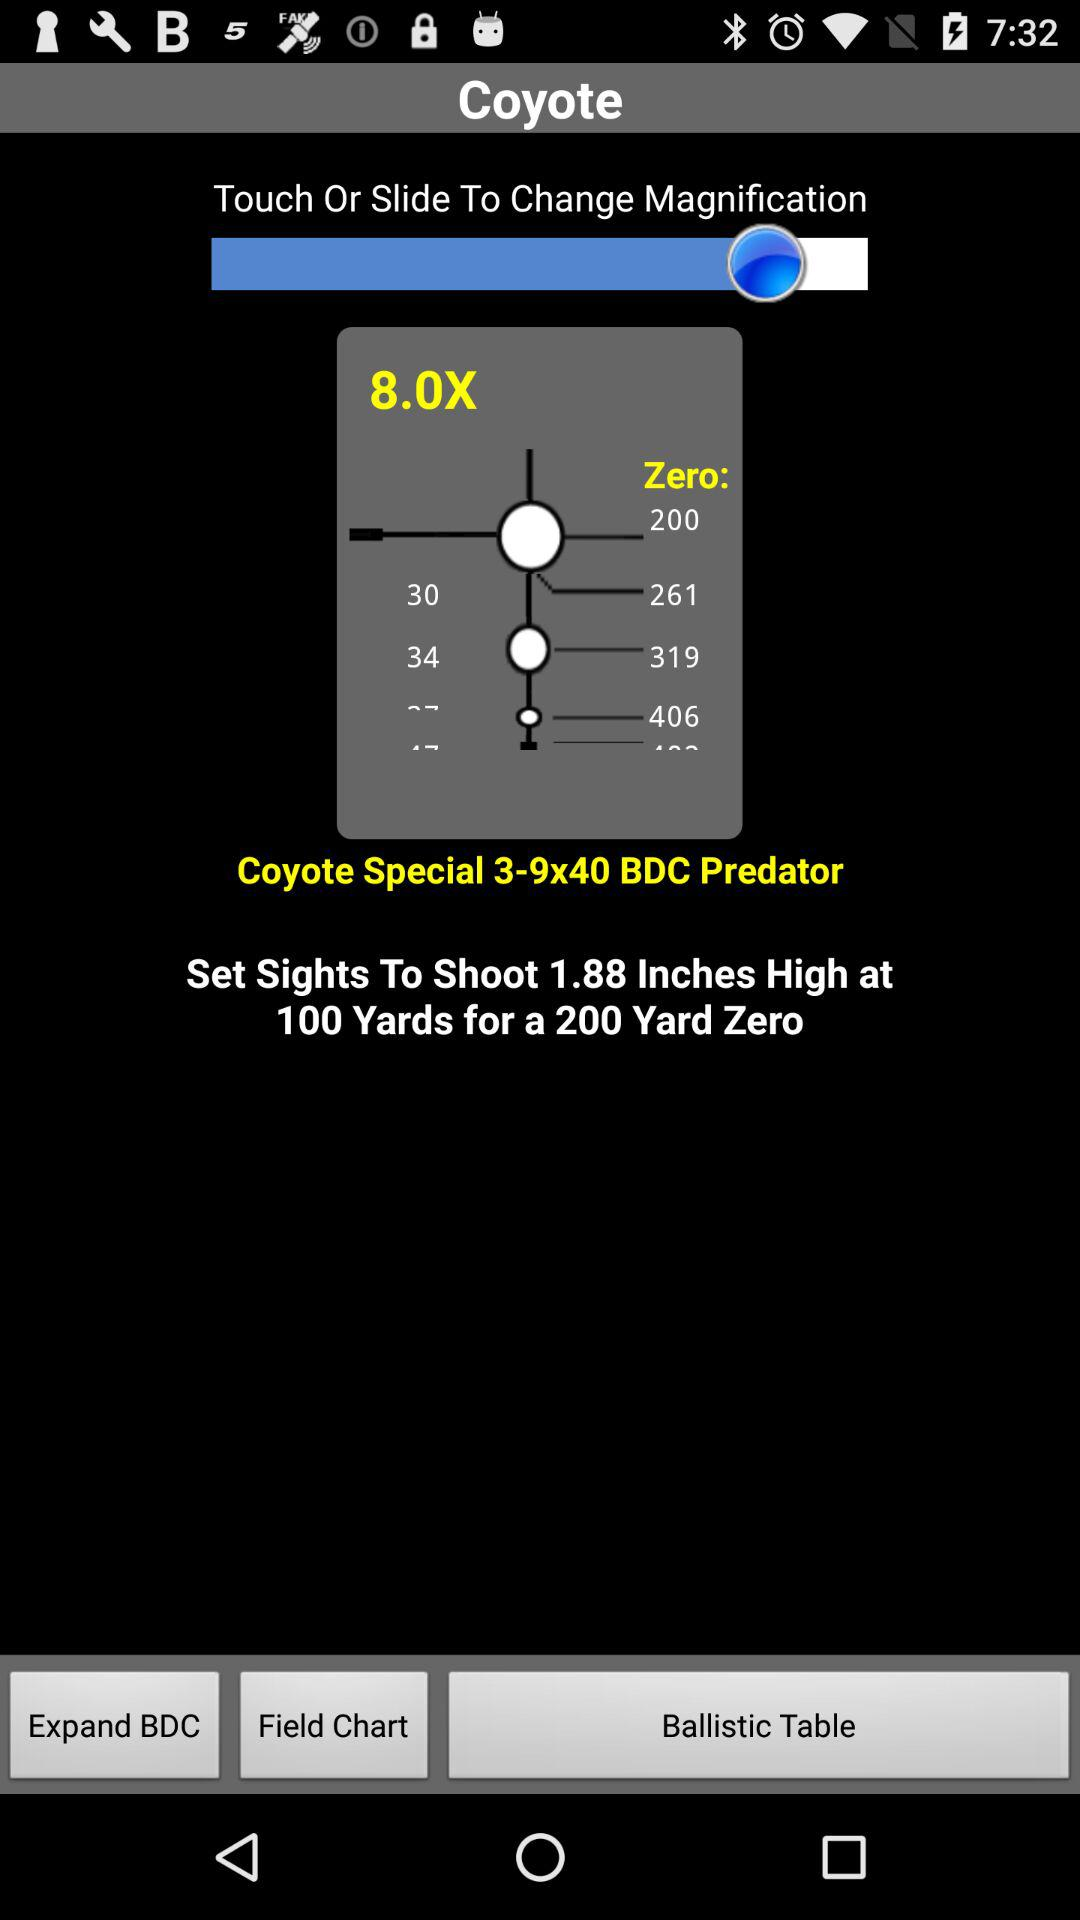What is the height of the zeroing mark in inches?
Answer the question using a single word or phrase. 1.88 